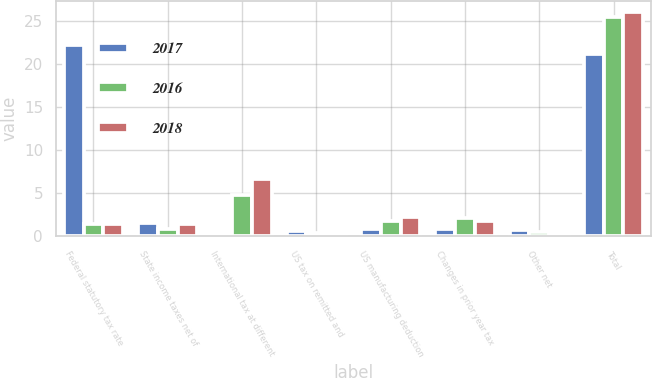Convert chart. <chart><loc_0><loc_0><loc_500><loc_500><stacked_bar_chart><ecel><fcel>Federal statutory tax rate<fcel>State income taxes net of<fcel>International tax at different<fcel>US tax on remitted and<fcel>US manufacturing deduction<fcel>Changes in prior year tax<fcel>Other net<fcel>Total<nl><fcel>2017<fcel>22.2<fcel>1.5<fcel>0.4<fcel>0.6<fcel>0.8<fcel>0.8<fcel>0.7<fcel>21.2<nl><fcel>2016<fcel>1.45<fcel>0.8<fcel>4.8<fcel>0.4<fcel>1.8<fcel>2.1<fcel>0.5<fcel>25.4<nl><fcel>2018<fcel>1.45<fcel>1.4<fcel>6.7<fcel>0.4<fcel>2.2<fcel>1.8<fcel>0.1<fcel>26<nl></chart> 